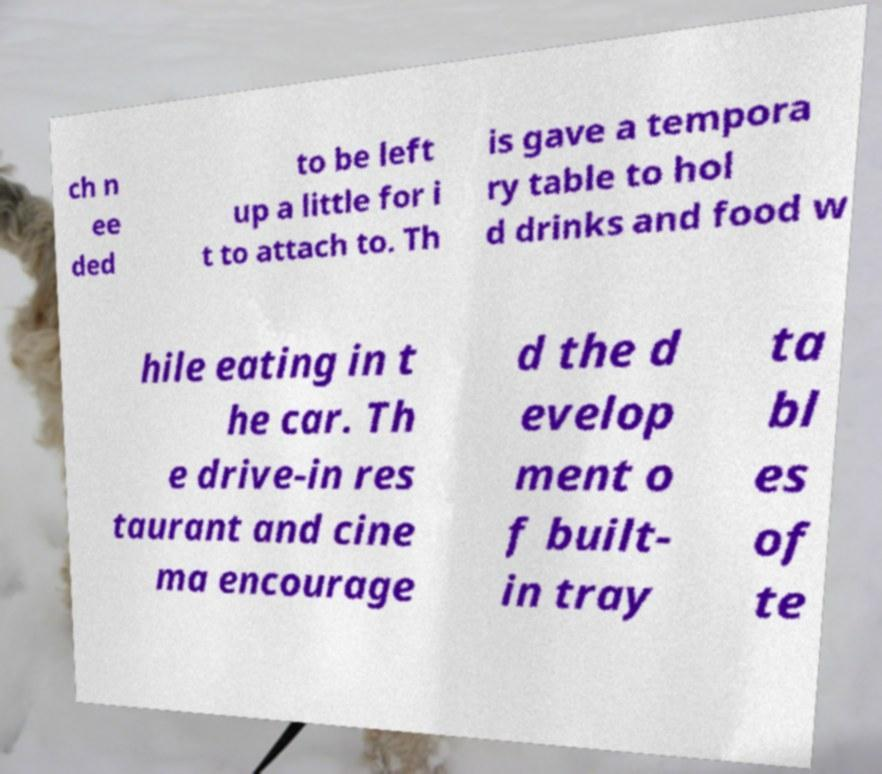Could you extract and type out the text from this image? ch n ee ded to be left up a little for i t to attach to. Th is gave a tempora ry table to hol d drinks and food w hile eating in t he car. Th e drive-in res taurant and cine ma encourage d the d evelop ment o f built- in tray ta bl es of te 